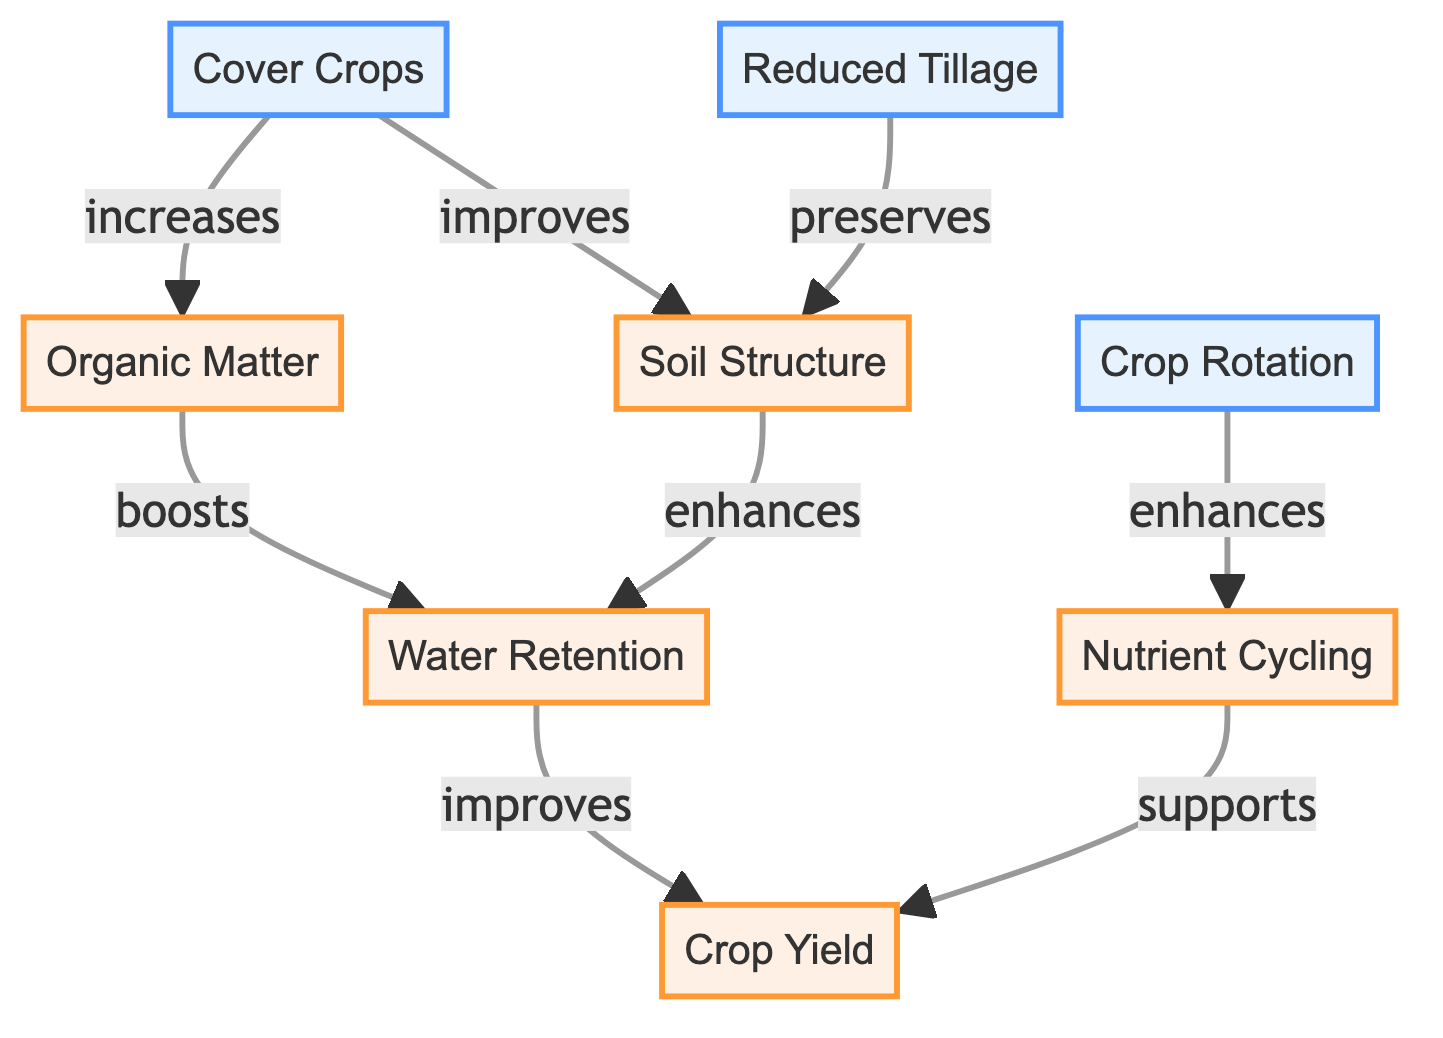What's the total number of nodes in the diagram? The diagram has 8 nodes representing various soil health practices and crop yield factors.
Answer: 8 Which practice improves soil structure? The diagram shows that both cover crops and reduced tillage improve soil structure.
Answer: cover crops, reduced tillage What does organic matter boost? According to the diagram, organic matter boosts water retention.
Answer: water retention How many edges are there in the diagram? The diagram contains 7 edges that describe the relationships between the nodes.
Answer: 7 Which practice enhances nutrient cycling? The diagram displays that crop rotation enhances nutrient cycling.
Answer: crop rotation If water retention improves, what is the expected impact on crop yield? The diagram indicates that if water retention improves, it leads to an improvement in crop yield.
Answer: improves Which two nodes directly connect to crop yield? The diagram shows that both water retention and nutrient cycling directly support crop yield.
Answer: water retention, nutrient cycling What is the relationship between cover crops and organic matter? Cover crops increase organic matter, as indicated in the diagram.
Answer: increases Which practice has a direct effect on crop yield through nutrient cycling? Crop rotation has a direct effect on crop yield through nutrient cycling, as depicted in the diagram.
Answer: crop rotation 